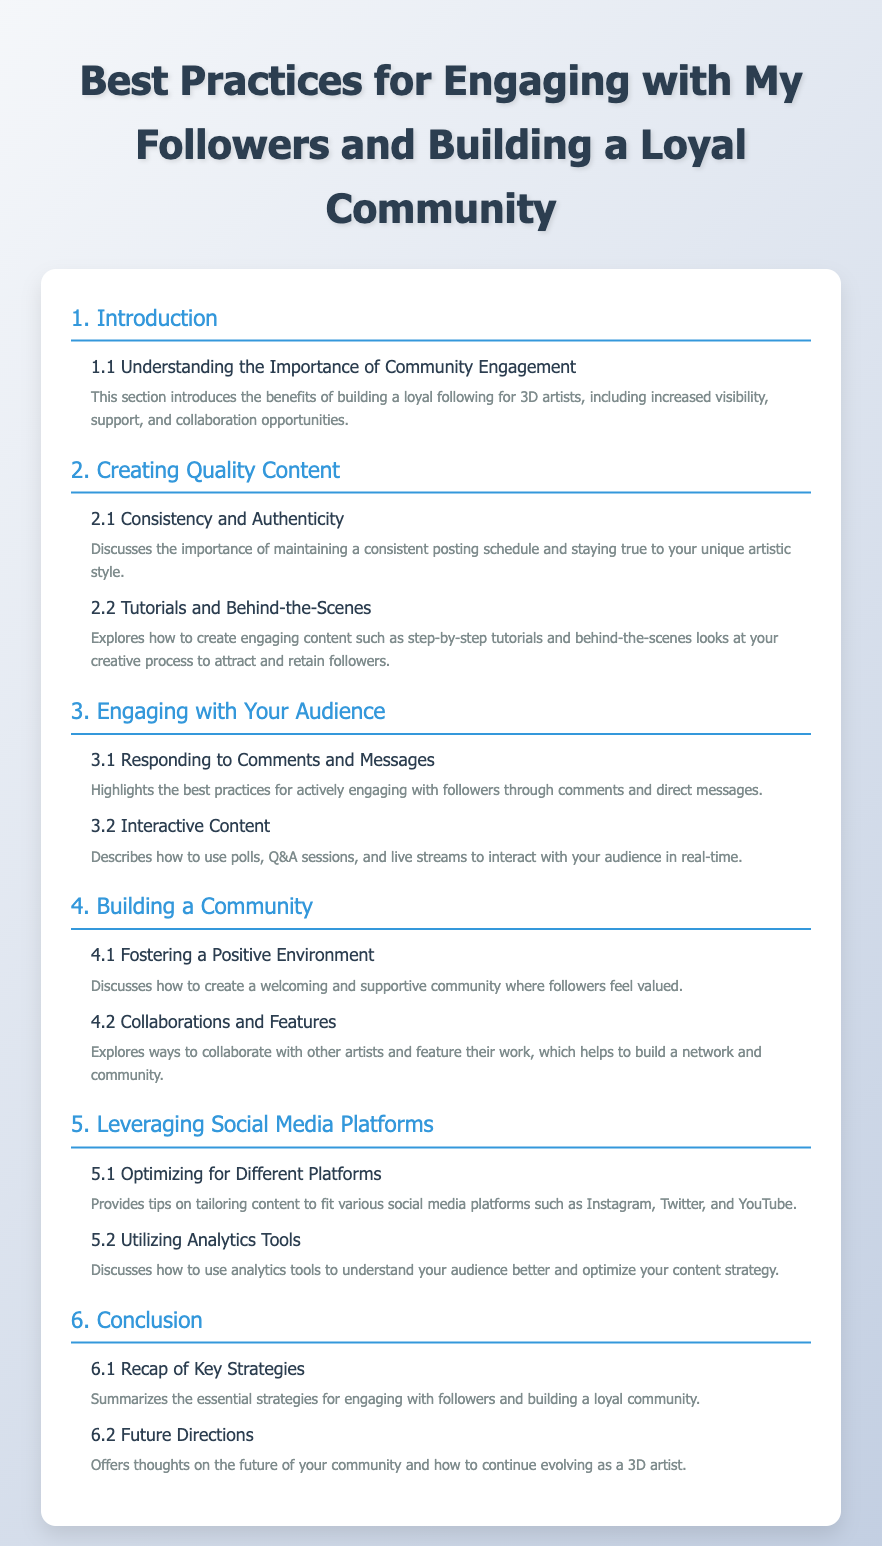What is the title of the document? The title of the document is listed prominently at the top of the rendered content.
Answer: Best Practices for Engaging with My Followers and Building a Loyal Community What is the main section that discusses content creation? The title "Creating Quality Content" indicates the focus of this section within the Table of Contents.
Answer: Creating Quality Content Which subsection covers tutorials? The term "Tutorials" is specifically mentioned in the subsection that relates to engaging content.
Answer: Tutorials and Behind-the-Scenes How many main sections are in the document? The document lists six main sections in its Table of Contents.
Answer: 6 What is the focus of section 4.1? Section 4.1 is about creating a welcoming environment for community members, as described in the title.
Answer: Fostering a Positive Environment Which social media aspect is highlighted in subsection 5.2? Subsection 5.2 discusses the importance of using tools to analyze audience engagement.
Answer: Utilizing Analytics Tools What strategy is reiterated in the conclusion? The conclusion summarizes key tactics for maintaining follower engagement and community building.
Answer: Recap of Key Strategies What is the benefit of community engagement according to section 1.1? Section 1.1 highlights benefits such as increased visibility and collaboration opportunities.
Answer: Increased visibility, support, and collaboration opportunities 